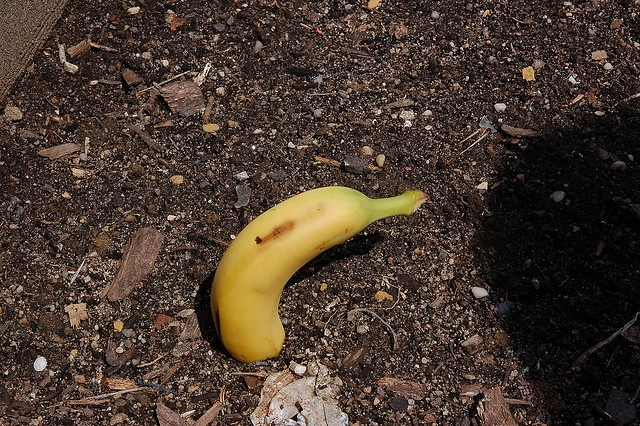Describe the objects in this image and their specific colors. I can see a banana in gray, tan, and olive tones in this image. 